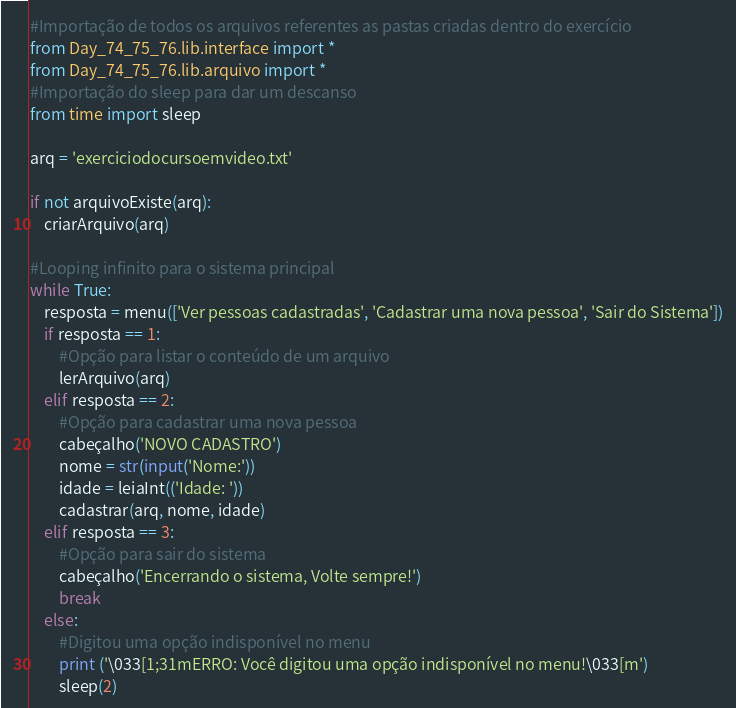Convert code to text. <code><loc_0><loc_0><loc_500><loc_500><_Python_>#Importação de todos os arquivos referentes as pastas criadas dentro do exercício
from Day_74_75_76.lib.interface import *
from Day_74_75_76.lib.arquivo import *
#Importação do sleep para dar um descanso
from time import sleep

arq = 'exerciciodocursoemvideo.txt'

if not arquivoExiste(arq):
    criarArquivo(arq)

#Looping infinito para o sistema principal
while True:
    resposta = menu(['Ver pessoas cadastradas', 'Cadastrar uma nova pessoa', 'Sair do Sistema'])
    if resposta == 1:
        #Opção para listar o conteúdo de um arquivo
        lerArquivo(arq)
    elif resposta == 2:
        #Opção para cadastrar uma nova pessoa
        cabeçalho('NOVO CADASTRO')
        nome = str(input('Nome:'))
        idade = leiaInt(('Idade: '))
        cadastrar(arq, nome, idade)
    elif resposta == 3:
        #Opção para sair do sistema
        cabeçalho('Encerrando o sistema, Volte sempre!')
        break
    else:
        #Digitou uma opção indisponível no menu
        print ('\033[1;31mERRO: Você digitou uma opção indisponível no menu!\033[m')
        sleep(2)</code> 